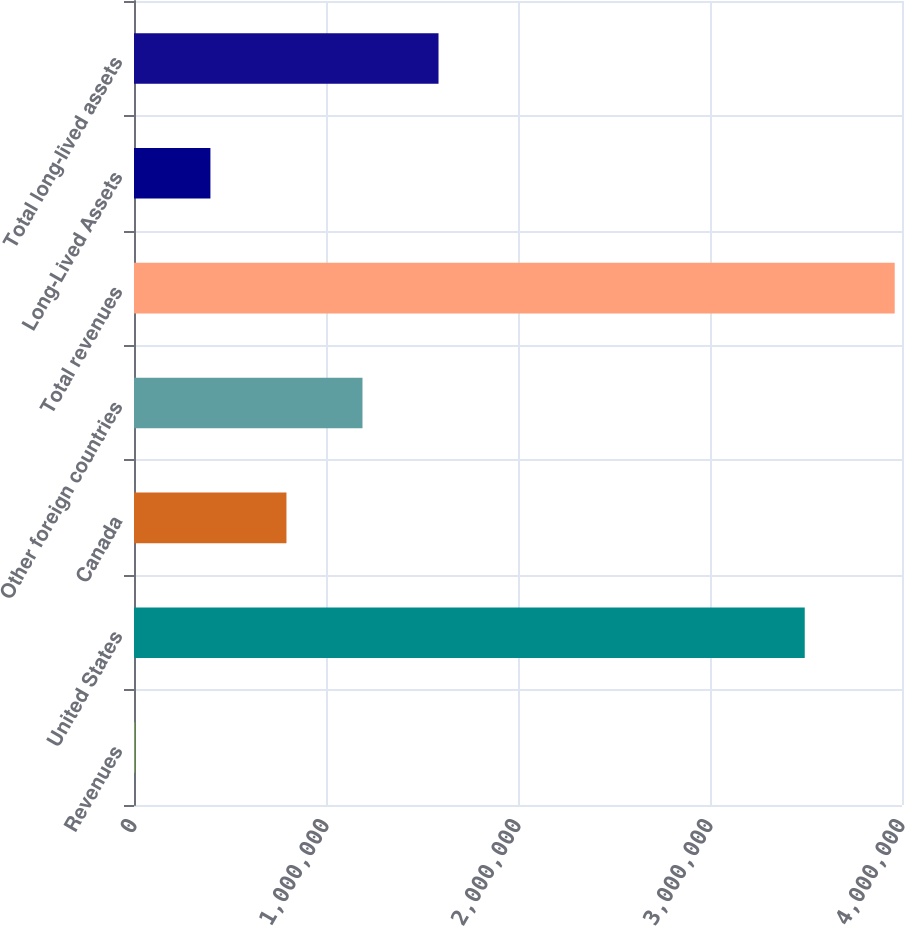Convert chart. <chart><loc_0><loc_0><loc_500><loc_500><bar_chart><fcel>Revenues<fcel>United States<fcel>Canada<fcel>Other foreign countries<fcel>Total revenues<fcel>Long-Lived Assets<fcel>Total long-lived assets<nl><fcel>2016<fcel>3.49346e+06<fcel>794020<fcel>1.19002e+06<fcel>3.96204e+06<fcel>398018<fcel>1.58602e+06<nl></chart> 